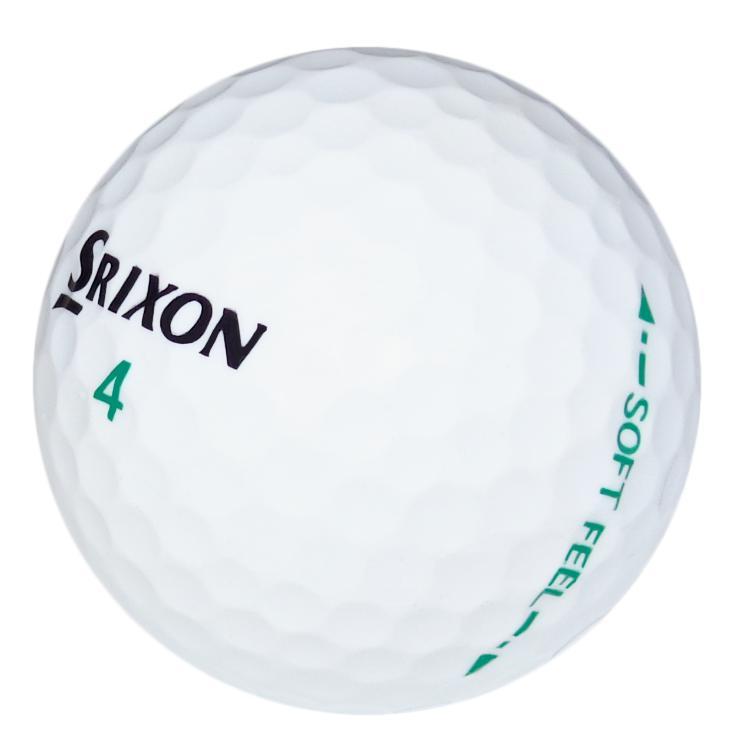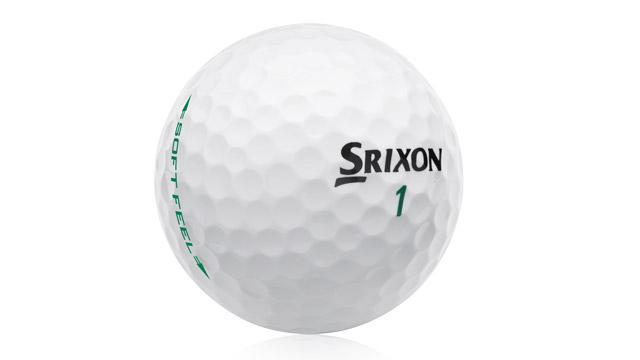The first image is the image on the left, the second image is the image on the right. For the images shown, is this caption "The object in the image on the left is mostly green." true? Answer yes or no. No. 